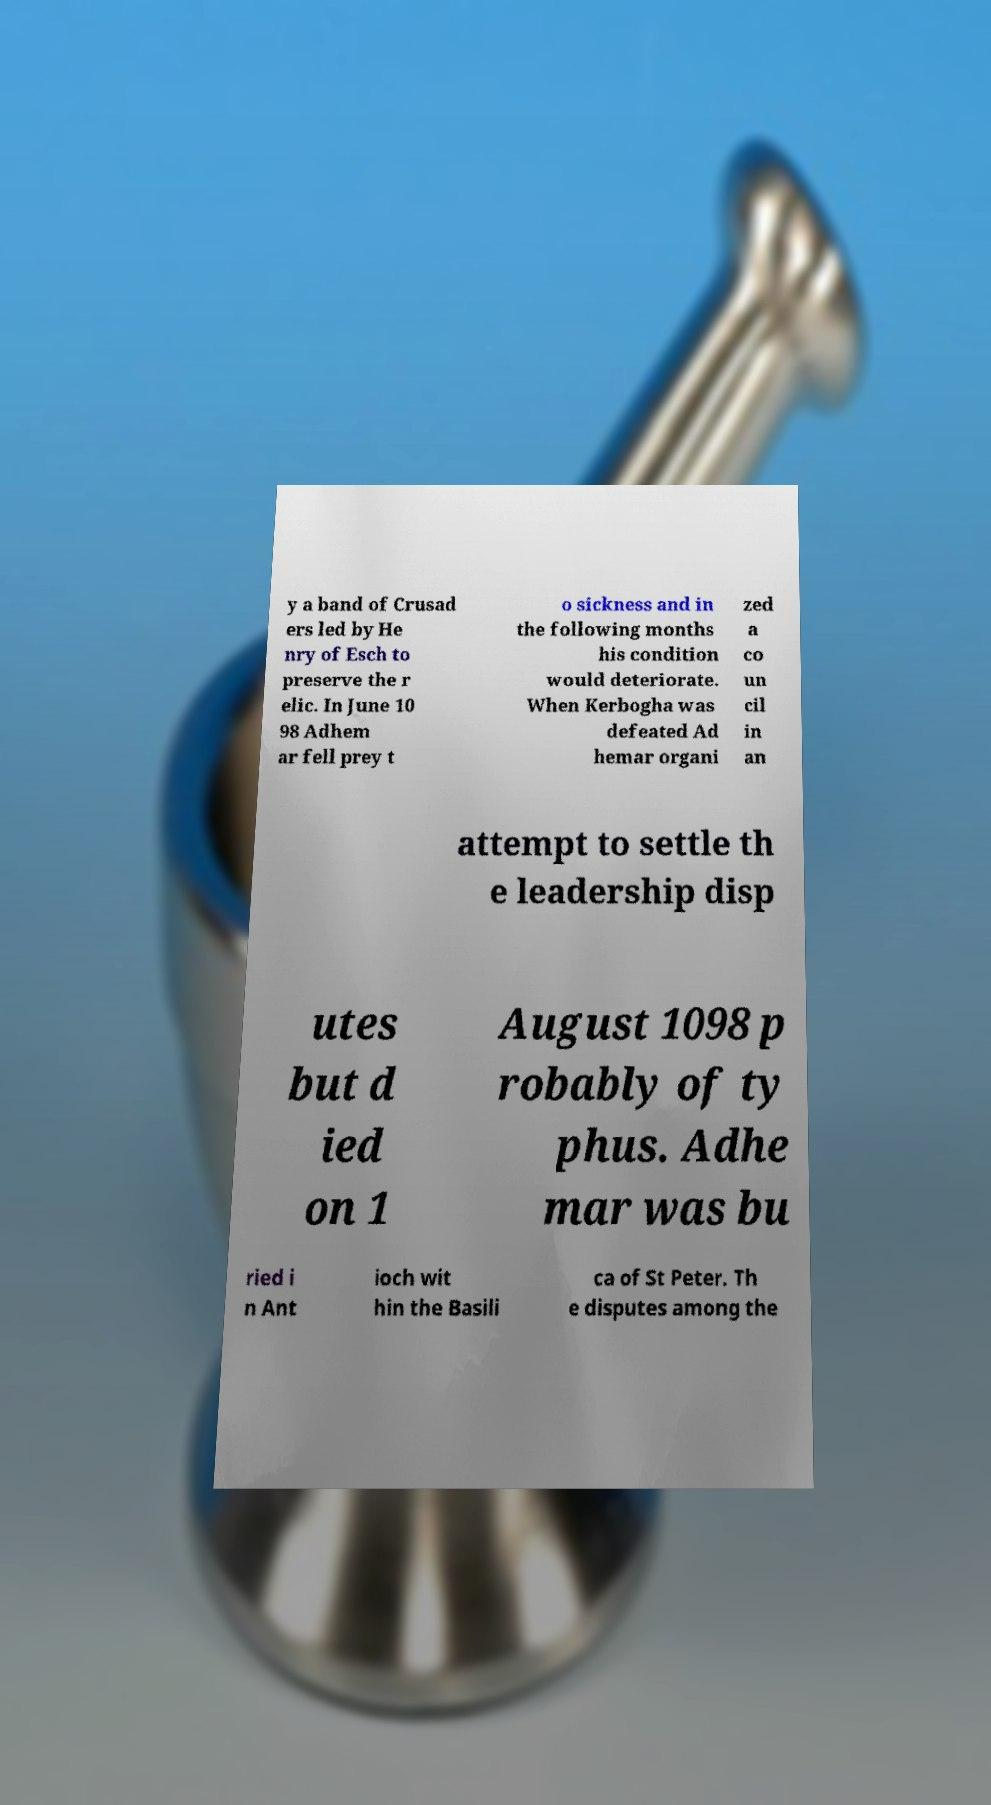Could you assist in decoding the text presented in this image and type it out clearly? y a band of Crusad ers led by He nry of Esch to preserve the r elic. In June 10 98 Adhem ar fell prey t o sickness and in the following months his condition would deteriorate. When Kerbogha was defeated Ad hemar organi zed a co un cil in an attempt to settle th e leadership disp utes but d ied on 1 August 1098 p robably of ty phus. Adhe mar was bu ried i n Ant ioch wit hin the Basili ca of St Peter. Th e disputes among the 